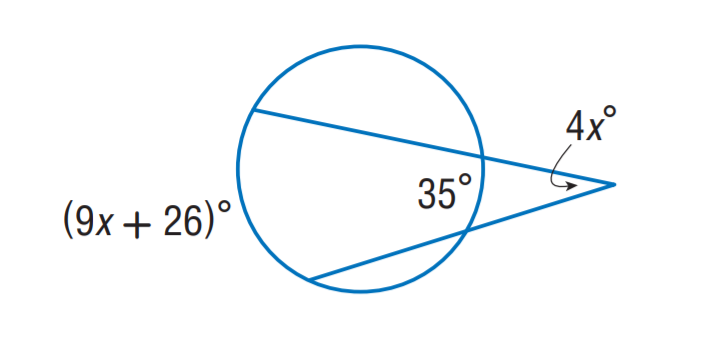Question: Find x.
Choices:
A. 9
B. 17.5
C. 26
D. 36
Answer with the letter. Answer: A 